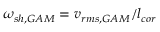Convert formula to latex. <formula><loc_0><loc_0><loc_500><loc_500>\omega _ { s h , G A M } = v _ { r m s , G A M } / l _ { c o r }</formula> 